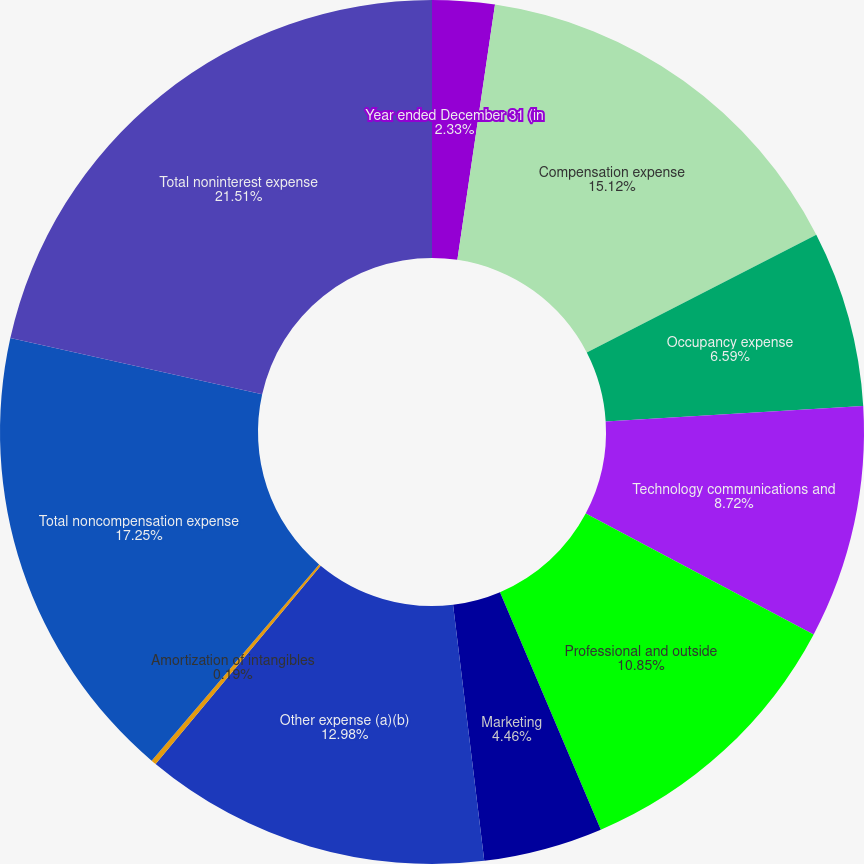<chart> <loc_0><loc_0><loc_500><loc_500><pie_chart><fcel>Year ended December 31 (in<fcel>Compensation expense<fcel>Occupancy expense<fcel>Technology communications and<fcel>Professional and outside<fcel>Marketing<fcel>Other expense (a)(b)<fcel>Amortization of intangibles<fcel>Total noncompensation expense<fcel>Total noninterest expense<nl><fcel>2.33%<fcel>15.12%<fcel>6.59%<fcel>8.72%<fcel>10.85%<fcel>4.46%<fcel>12.98%<fcel>0.19%<fcel>17.25%<fcel>21.51%<nl></chart> 